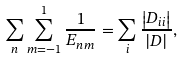Convert formula to latex. <formula><loc_0><loc_0><loc_500><loc_500>\sum _ { n } \sum _ { m = - 1 } ^ { 1 } \frac { 1 } { E _ { n m } } = \sum _ { i } \frac { \left | D _ { i i } \right | } { | D | } ,</formula> 